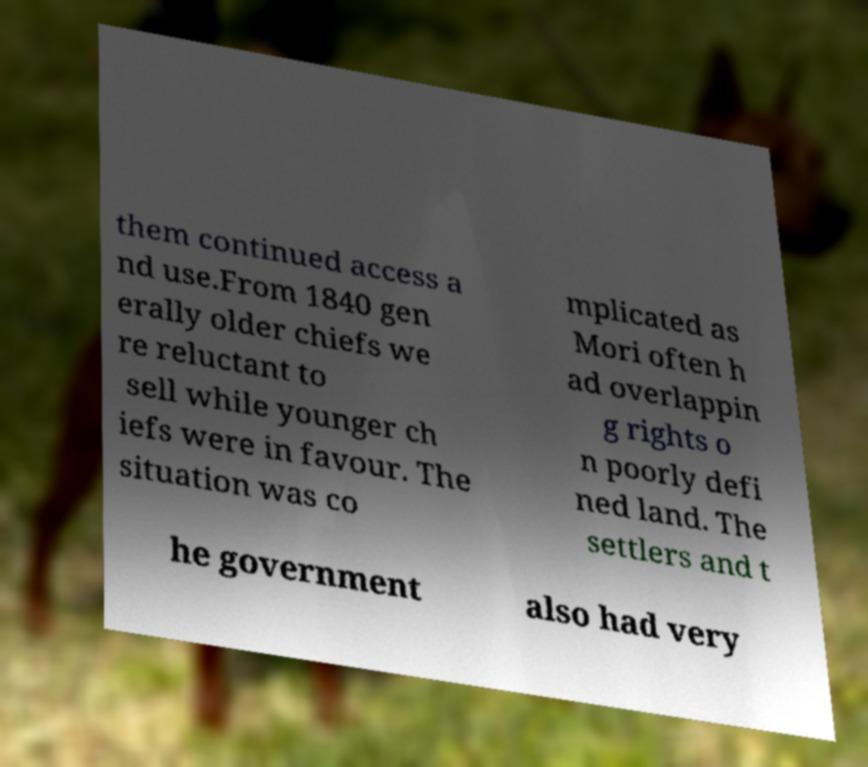What messages or text are displayed in this image? I need them in a readable, typed format. them continued access a nd use.From 1840 gen erally older chiefs we re reluctant to sell while younger ch iefs were in favour. The situation was co mplicated as Mori often h ad overlappin g rights o n poorly defi ned land. The settlers and t he government also had very 